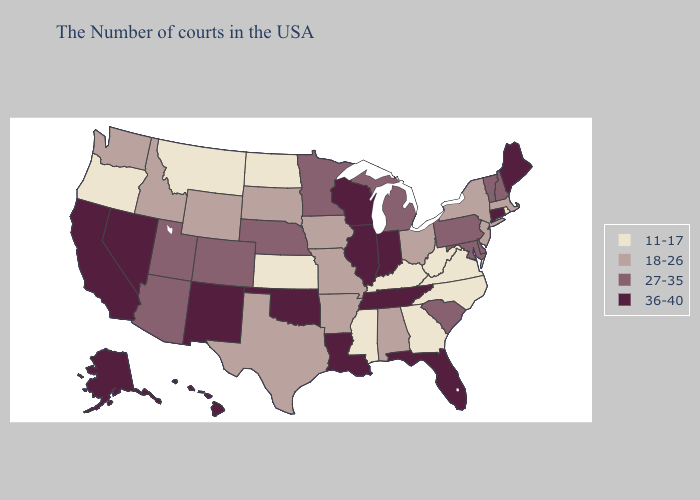Name the states that have a value in the range 11-17?
Answer briefly. Rhode Island, Virginia, North Carolina, West Virginia, Georgia, Kentucky, Mississippi, Kansas, North Dakota, Montana, Oregon. Name the states that have a value in the range 27-35?
Be succinct. New Hampshire, Vermont, Delaware, Maryland, Pennsylvania, South Carolina, Michigan, Minnesota, Nebraska, Colorado, Utah, Arizona. Name the states that have a value in the range 27-35?
Answer briefly. New Hampshire, Vermont, Delaware, Maryland, Pennsylvania, South Carolina, Michigan, Minnesota, Nebraska, Colorado, Utah, Arizona. Which states have the lowest value in the Northeast?
Be succinct. Rhode Island. What is the lowest value in the USA?
Answer briefly. 11-17. Does New Mexico have the highest value in the West?
Be succinct. Yes. What is the value of Wisconsin?
Write a very short answer. 36-40. Among the states that border Maryland , does Delaware have the lowest value?
Be succinct. No. How many symbols are there in the legend?
Concise answer only. 4. Name the states that have a value in the range 36-40?
Short answer required. Maine, Connecticut, Florida, Indiana, Tennessee, Wisconsin, Illinois, Louisiana, Oklahoma, New Mexico, Nevada, California, Alaska, Hawaii. Does Minnesota have the lowest value in the USA?
Keep it brief. No. Does Illinois have the highest value in the USA?
Write a very short answer. Yes. What is the highest value in the USA?
Be succinct. 36-40. Name the states that have a value in the range 27-35?
Concise answer only. New Hampshire, Vermont, Delaware, Maryland, Pennsylvania, South Carolina, Michigan, Minnesota, Nebraska, Colorado, Utah, Arizona. Which states have the highest value in the USA?
Short answer required. Maine, Connecticut, Florida, Indiana, Tennessee, Wisconsin, Illinois, Louisiana, Oklahoma, New Mexico, Nevada, California, Alaska, Hawaii. 